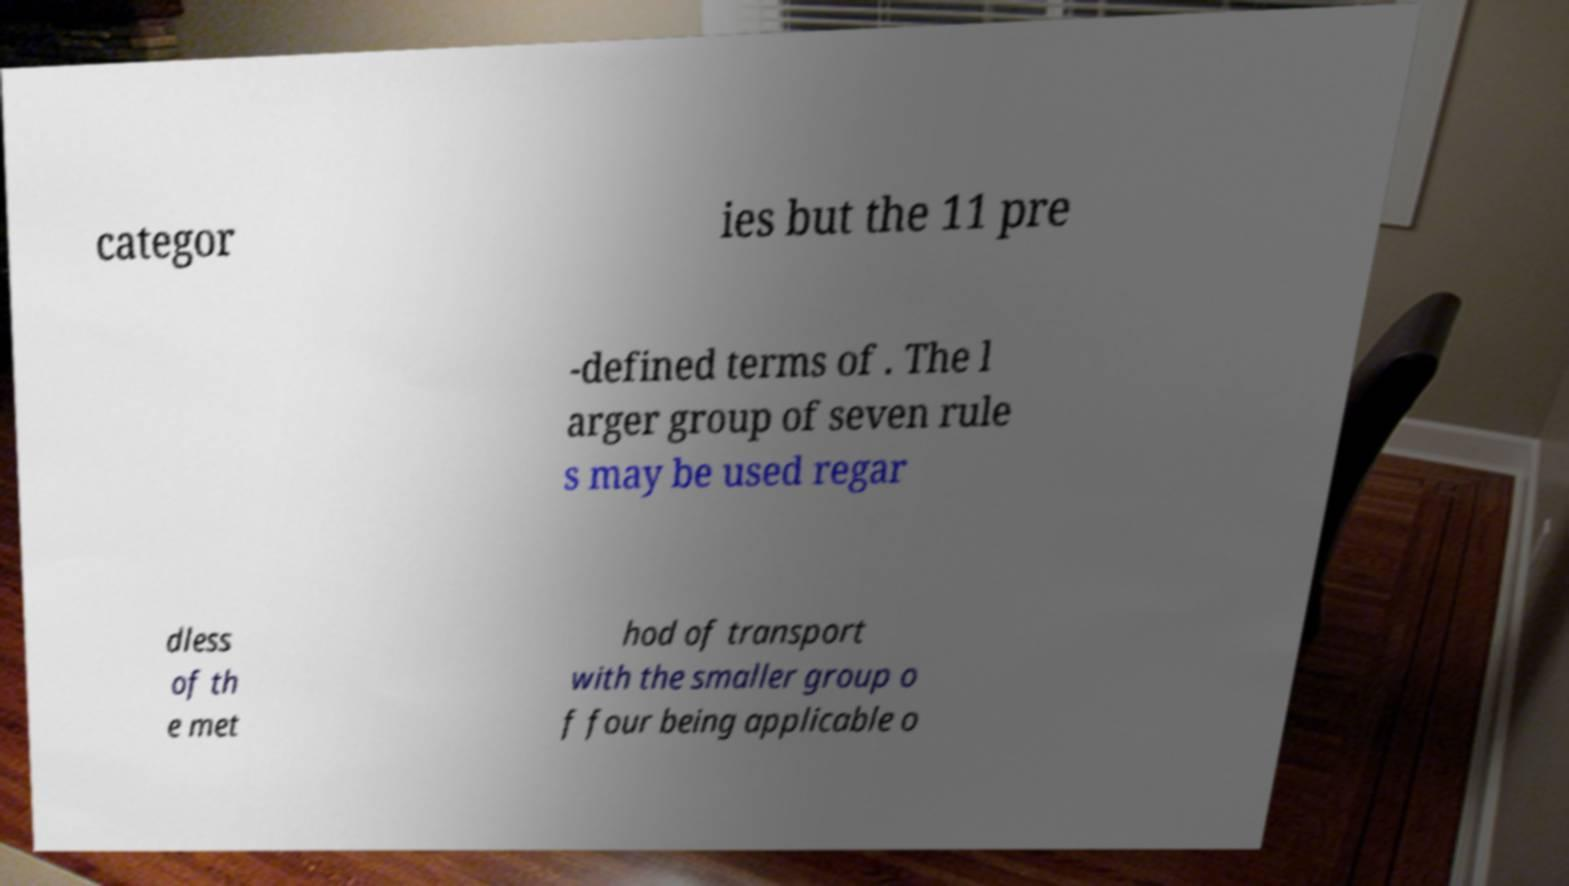Could you extract and type out the text from this image? categor ies but the 11 pre -defined terms of . The l arger group of seven rule s may be used regar dless of th e met hod of transport with the smaller group o f four being applicable o 